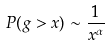<formula> <loc_0><loc_0><loc_500><loc_500>P ( g > x ) \sim \frac { 1 } { x ^ { \alpha } }</formula> 